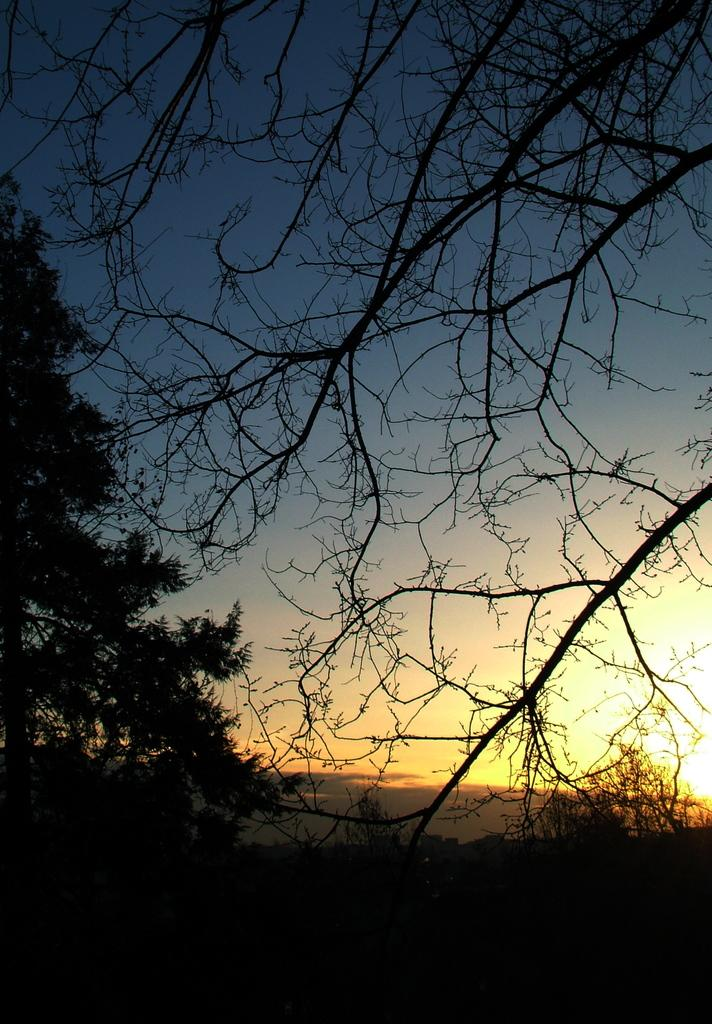What type of vegetation is visible on the ground in the image? There are trees on the ground in the image. What celestial body can be seen in the background of the image? The sun is visible in the background of the image. What atmospheric feature is present in the sky in the background of the image? Clouds are present in the sky in the background of the image. What is the opinion of the yak about the weather in the image? There is no yak present in the image, so it is not possible to determine its opinion about the weather. 